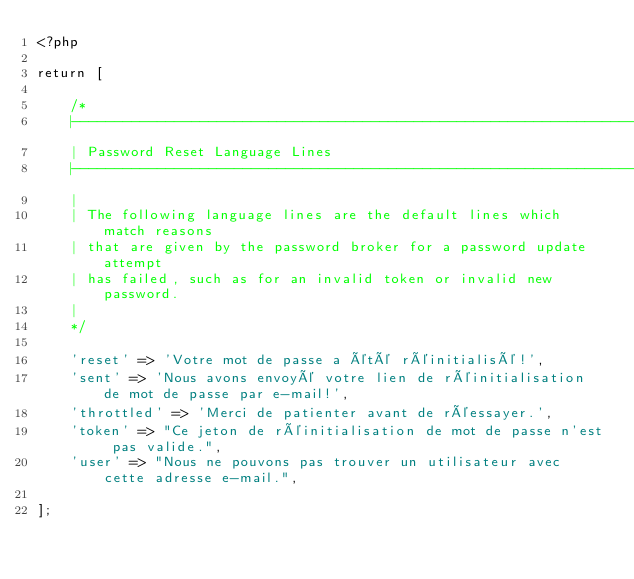<code> <loc_0><loc_0><loc_500><loc_500><_PHP_><?php

return [

    /*
    |--------------------------------------------------------------------------
    | Password Reset Language Lines
    |--------------------------------------------------------------------------
    |
    | The following language lines are the default lines which match reasons
    | that are given by the password broker for a password update attempt
    | has failed, such as for an invalid token or invalid new password.
    |
    */

    'reset' => 'Votre mot de passe a été réinitialisé!',
    'sent' => 'Nous avons envoyé votre lien de réinitialisation de mot de passe par e-mail!',
    'throttled' => 'Merci de patienter avant de réessayer.',
    'token' => "Ce jeton de réinitialisation de mot de passe n'est pas valide.",
    'user' => "Nous ne pouvons pas trouver un utilisateur avec cette adresse e-mail.",

];
</code> 